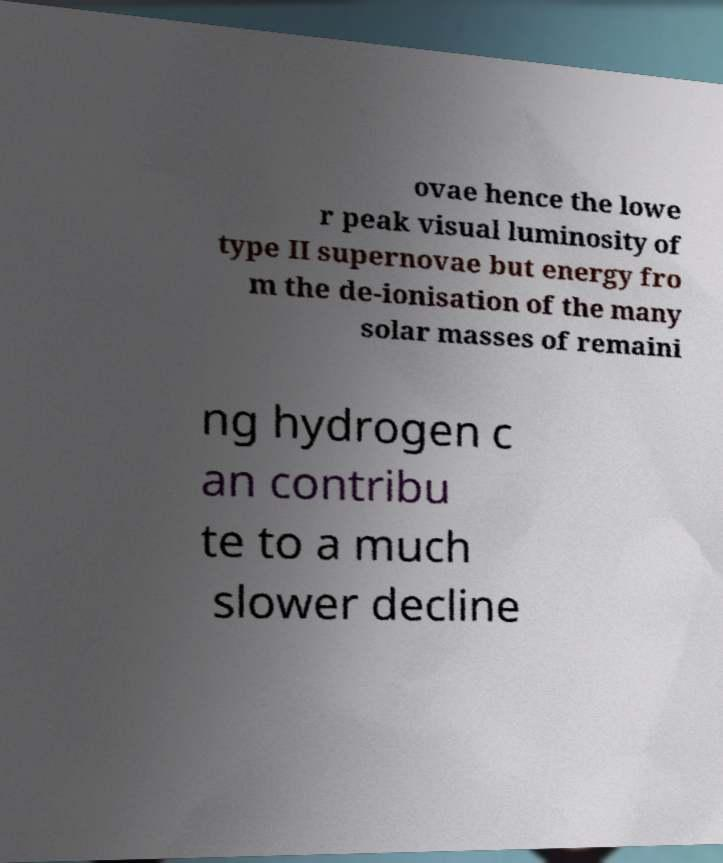Can you read and provide the text displayed in the image?This photo seems to have some interesting text. Can you extract and type it out for me? ovae hence the lowe r peak visual luminosity of type II supernovae but energy fro m the de-ionisation of the many solar masses of remaini ng hydrogen c an contribu te to a much slower decline 